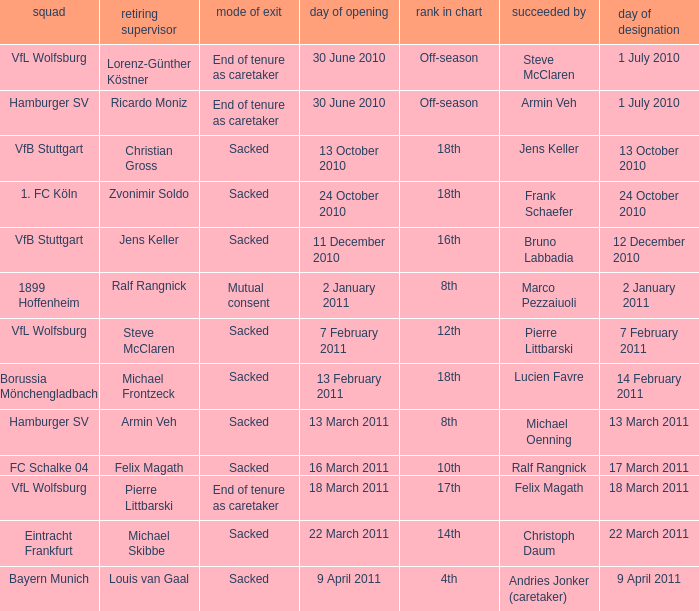When 1. fc köln is the team what is the date of appointment? 24 October 2010. 